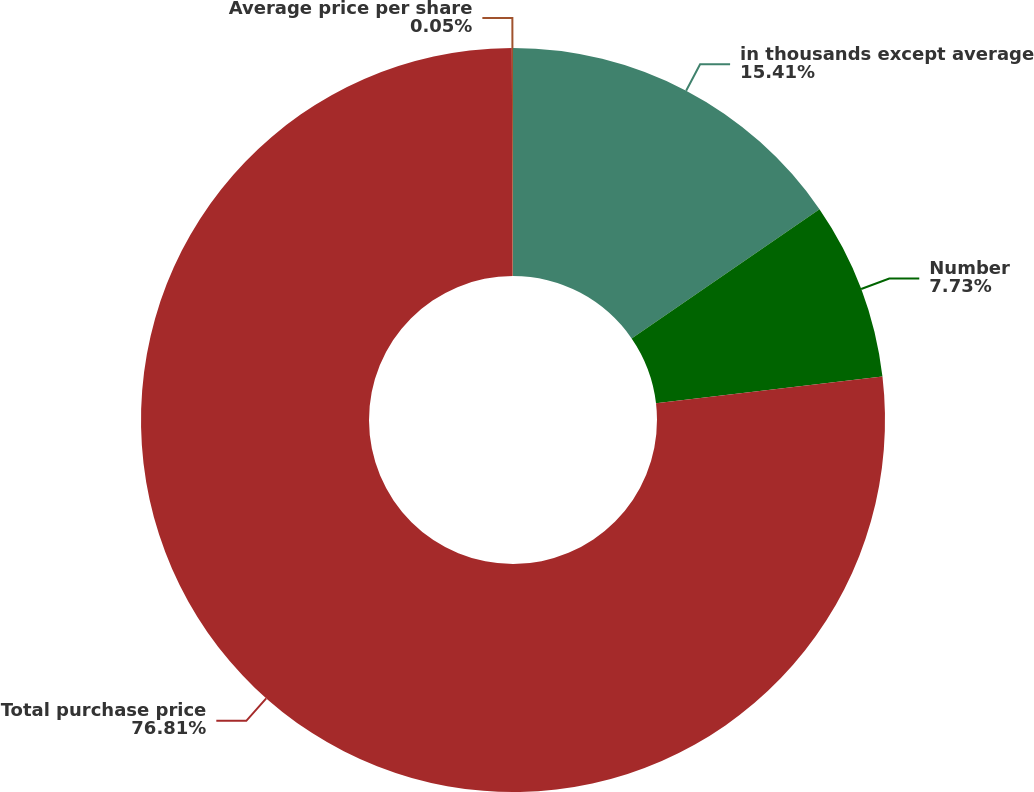Convert chart to OTSL. <chart><loc_0><loc_0><loc_500><loc_500><pie_chart><fcel>in thousands except average<fcel>Number<fcel>Total purchase price<fcel>Average price per share<nl><fcel>15.41%<fcel>7.73%<fcel>76.81%<fcel>0.05%<nl></chart> 